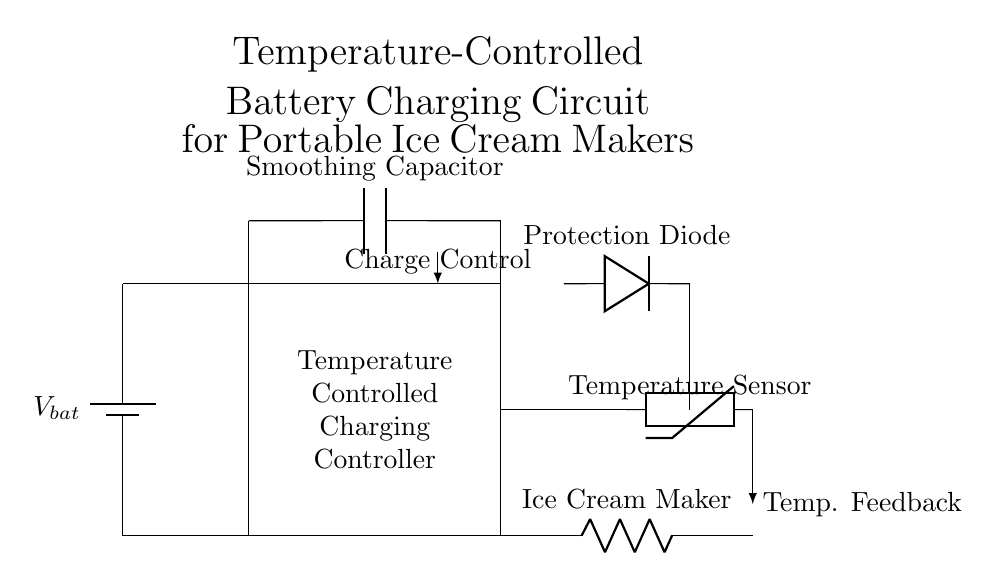What is the main component used for charge control? The main component for charge control is the Temperature Controlled Charging Controller, as labeled in the circuit diagram.
Answer: Temperature Controlled Charging Controller What does the thermistor represent in this circuit? The thermistor represents the temperature sensor, which monitors the temperature to regulate the charging process effectively.
Answer: Temperature sensor How many connections are there from the battery? There are two connections from the battery: one at the positive terminal connected to the top of the controller and one at the negative terminal connected to the bottom.
Answer: Two connections What type of load is represented in this circuit? The load represented in this circuit is the Ice Cream Maker, which consumes power from the battery via the charging controller.
Answer: Ice Cream Maker Which component provides voltage smoothing? The Smoothing Capacitor is responsible for providing voltage smoothing in the circuit, ensuring a stable voltage output to the load.
Answer: Smoothing Capacitor What role does the protection diode play in this circuit? The Protection Diode prevents reverse current flow, protecting the circuit components from damage when the power source is disconnected or reversed.
Answer: Prevents reverse current What feedback mechanism is shown in the circuit? The circuit includes a Temperature Feedback mechanism that informs the charge controller about the current temperature, allowing it to adjust the charging conditions.
Answer: Temperature Feedback 